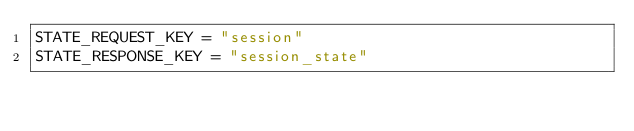Convert code to text. <code><loc_0><loc_0><loc_500><loc_500><_Python_>STATE_REQUEST_KEY = "session"
STATE_RESPONSE_KEY = "session_state"
</code> 